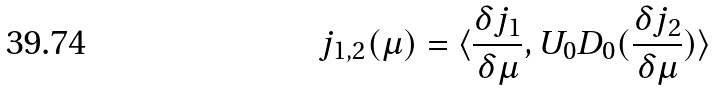<formula> <loc_0><loc_0><loc_500><loc_500>j _ { 1 , 2 } ( \mu ) = \langle \frac { \delta j _ { 1 } } { \delta \mu } , U _ { 0 } D _ { 0 } ( \frac { \delta j _ { 2 } } { \delta \mu } ) \rangle</formula> 